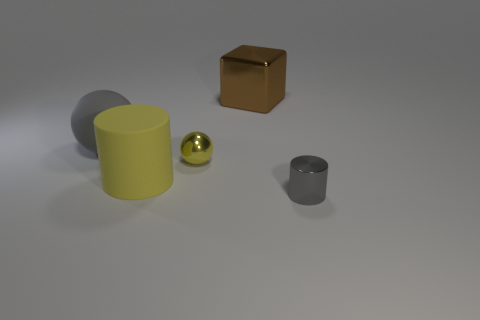What shape is the brown object?
Provide a succinct answer. Cube. Are there any other things that have the same color as the big rubber cylinder?
Offer a terse response. Yes. Does the sphere that is on the left side of the large cylinder have the same size as the object that is right of the block?
Your answer should be very brief. No. What is the shape of the small thing in front of the small metallic object behind the gray cylinder?
Give a very brief answer. Cylinder. There is a yellow sphere; does it have the same size as the gray object left of the small gray cylinder?
Offer a very short reply. No. How big is the shiny thing left of the large brown object behind the small metal ball that is to the left of the tiny gray metallic cylinder?
Keep it short and to the point. Small. How many things are either tiny objects that are to the left of the small metal cylinder or tiny gray shiny cylinders?
Your answer should be very brief. 2. There is a tiny object that is right of the large brown thing; how many small objects are behind it?
Offer a terse response. 1. Are there more spheres that are on the left side of the big yellow thing than purple metal cubes?
Ensure brevity in your answer.  Yes. There is a object that is to the right of the tiny yellow metallic thing and behind the yellow matte object; what size is it?
Your response must be concise. Large. 